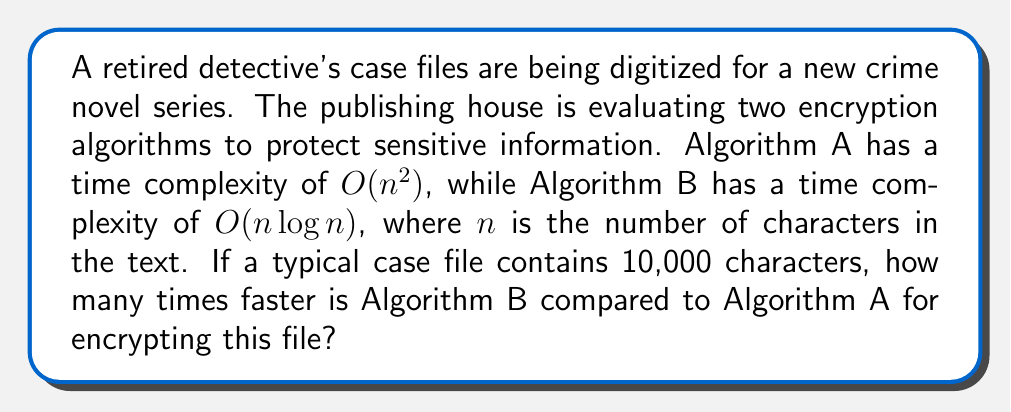Solve this math problem. To solve this problem, we need to compare the running times of both algorithms for $n = 10,000$ characters:

1. For Algorithm A with $O(n^2)$ complexity:
   $$T_A(n) = cn^2$$
   where $c$ is some constant factor.

2. For Algorithm B with $O(n \log n)$ complexity:
   $$T_B(n) = kn \log n$$
   where $k$ is some constant factor.

3. To compare the algorithms, we assume the constant factors are equal ($c = k = 1$) and calculate the ratio:

   $$\frac{T_A(n)}{T_B(n)} = \frac{n^2}{n \log n} = \frac{n}{\log n}$$

4. Substituting $n = 10,000$:

   $$\frac{T_A(10000)}{T_B(10000)} = \frac{10000}{\log 10000}$$

5. Calculate $\log 10000$:
   $$\log 10000 = \log (10^4) = 4 \log 10 \approx 4 \cdot 2.3026 \approx 9.2104$$

6. Final calculation:
   $$\frac{10000}{9.2104} \approx 1085.73$$

Therefore, Algorithm B is approximately 1085.73 times faster than Algorithm A for encrypting a 10,000-character case file.
Answer: Algorithm B is approximately 1086 times faster than Algorithm A for encrypting a 10,000-character case file. 